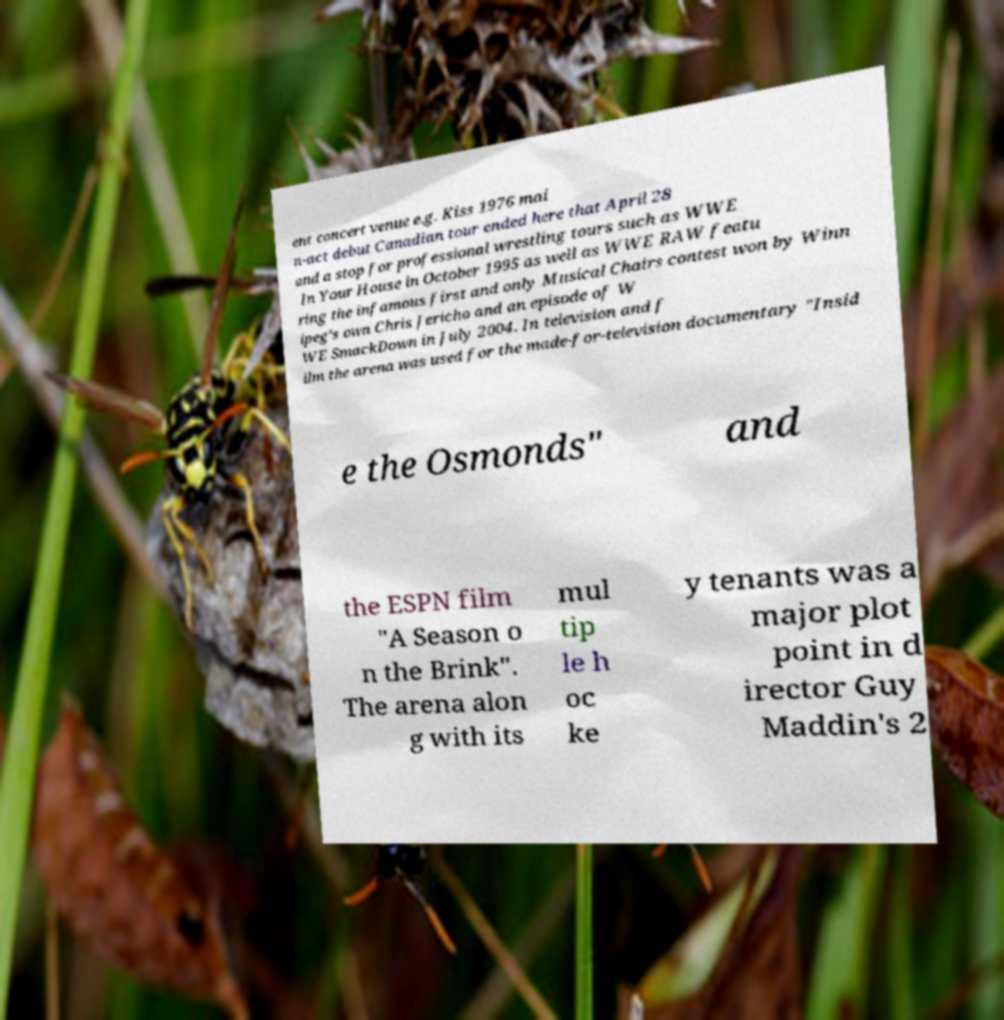Can you accurately transcribe the text from the provided image for me? ent concert venue e.g. Kiss 1976 mai n-act debut Canadian tour ended here that April 28 and a stop for professional wrestling tours such as WWE In Your House in October 1995 as well as WWE RAW featu ring the infamous first and only Musical Chairs contest won by Winn ipeg's own Chris Jericho and an episode of W WE SmackDown in July 2004. In television and f ilm the arena was used for the made-for-television documentary "Insid e the Osmonds" and the ESPN film "A Season o n the Brink". The arena alon g with its mul tip le h oc ke y tenants was a major plot point in d irector Guy Maddin's 2 